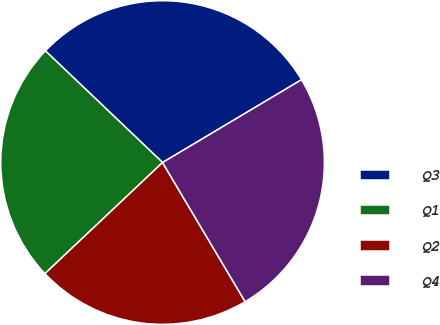<chart> <loc_0><loc_0><loc_500><loc_500><pie_chart><fcel>Q3<fcel>Q1<fcel>Q2<fcel>Q4<nl><fcel>29.33%<fcel>24.17%<fcel>21.48%<fcel>25.03%<nl></chart> 